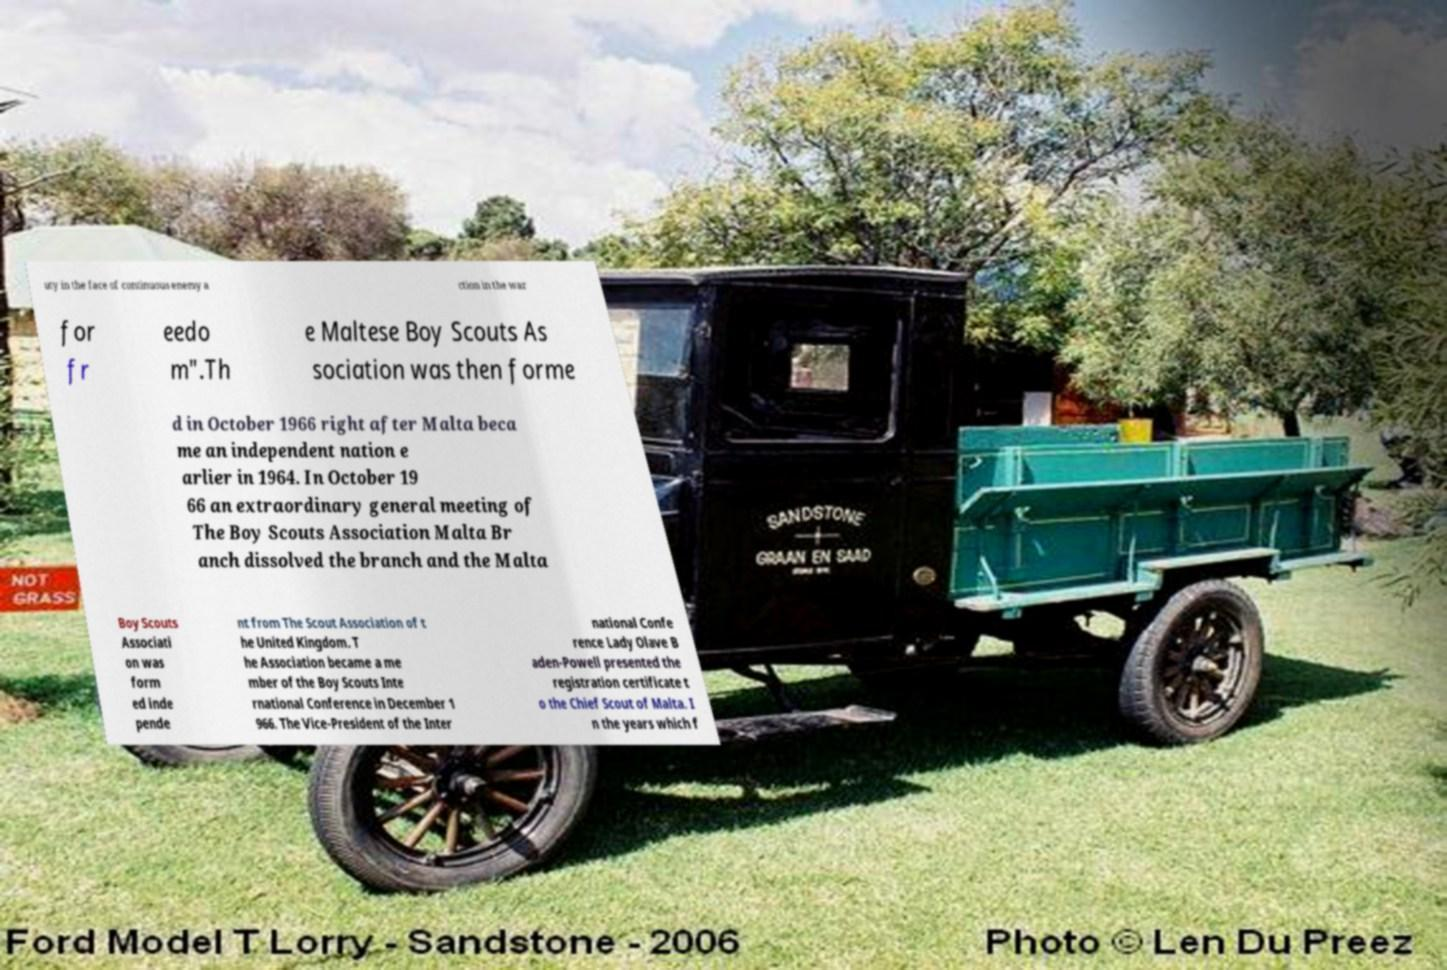I need the written content from this picture converted into text. Can you do that? uty in the face of continuous enemy a ction in the war for fr eedo m".Th e Maltese Boy Scouts As sociation was then forme d in October 1966 right after Malta beca me an independent nation e arlier in 1964. In October 19 66 an extraordinary general meeting of The Boy Scouts Association Malta Br anch dissolved the branch and the Malta Boy Scouts Associati on was form ed inde pende nt from The Scout Association of t he United Kingdom. T he Association became a me mber of the Boy Scouts Inte rnational Conference in December 1 966. The Vice-President of the Inter national Confe rence Lady Olave B aden-Powell presented the registration certificate t o the Chief Scout of Malta. I n the years which f 